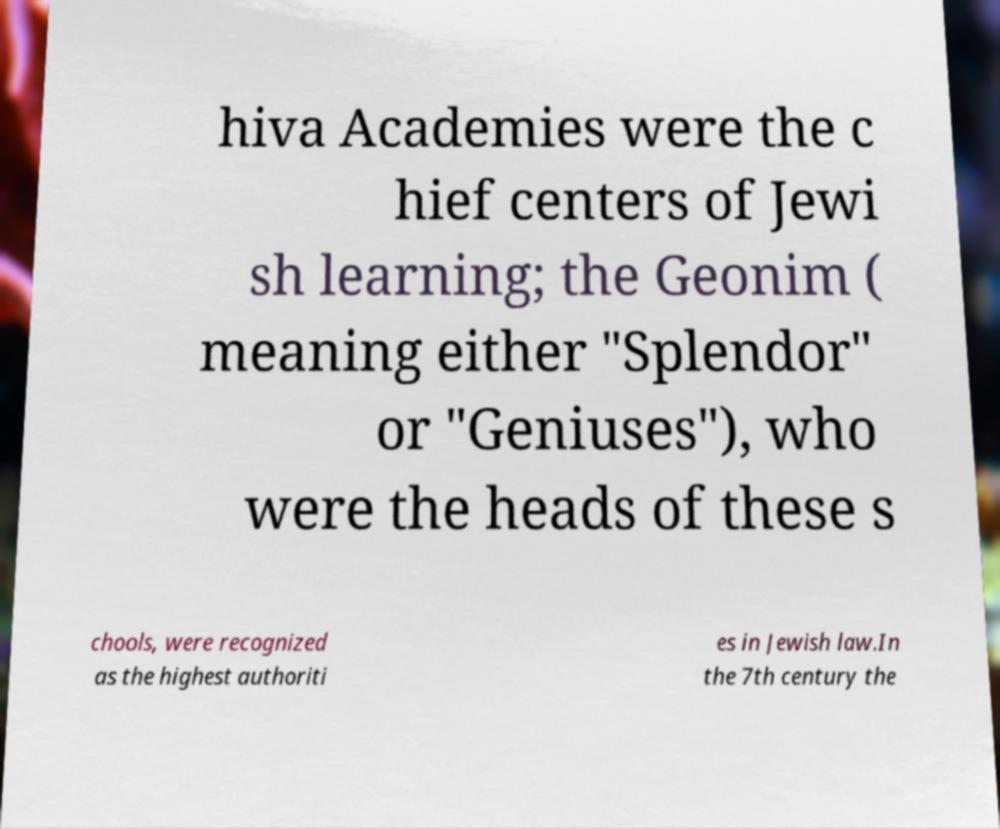Please read and relay the text visible in this image. What does it say? hiva Academies were the c hief centers of Jewi sh learning; the Geonim ( meaning either "Splendor" or "Geniuses"), who were the heads of these s chools, were recognized as the highest authoriti es in Jewish law.In the 7th century the 